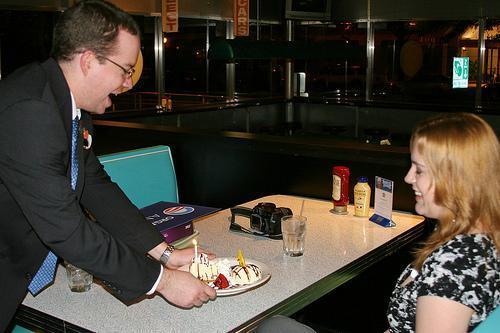How many candles?
Give a very brief answer. 2. 